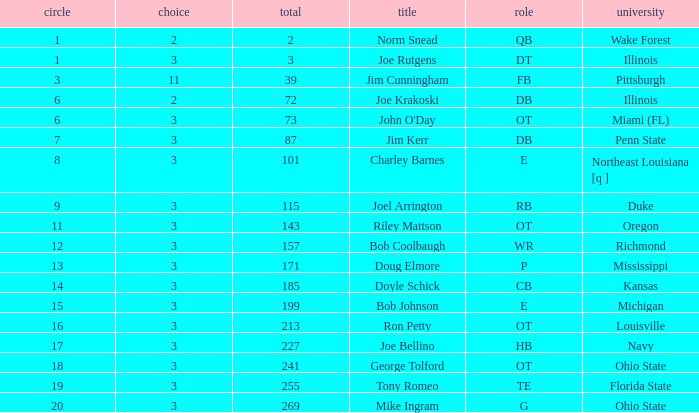Could you help me parse every detail presented in this table? {'header': ['circle', 'choice', 'total', 'title', 'role', 'university'], 'rows': [['1', '2', '2', 'Norm Snead', 'QB', 'Wake Forest'], ['1', '3', '3', 'Joe Rutgens', 'DT', 'Illinois'], ['3', '11', '39', 'Jim Cunningham', 'FB', 'Pittsburgh'], ['6', '2', '72', 'Joe Krakoski', 'DB', 'Illinois'], ['6', '3', '73', "John O'Day", 'OT', 'Miami (FL)'], ['7', '3', '87', 'Jim Kerr', 'DB', 'Penn State'], ['8', '3', '101', 'Charley Barnes', 'E', 'Northeast Louisiana [q ]'], ['9', '3', '115', 'Joel Arrington', 'RB', 'Duke'], ['11', '3', '143', 'Riley Mattson', 'OT', 'Oregon'], ['12', '3', '157', 'Bob Coolbaugh', 'WR', 'Richmond'], ['13', '3', '171', 'Doug Elmore', 'P', 'Mississippi'], ['14', '3', '185', 'Doyle Schick', 'CB', 'Kansas'], ['15', '3', '199', 'Bob Johnson', 'E', 'Michigan'], ['16', '3', '213', 'Ron Petty', 'OT', 'Louisville'], ['17', '3', '227', 'Joe Bellino', 'HB', 'Navy'], ['18', '3', '241', 'George Tolford', 'OT', 'Ohio State'], ['19', '3', '255', 'Tony Romeo', 'TE', 'Florida State'], ['20', '3', '269', 'Mike Ingram', 'G', 'Ohio State']]} How many overalls have charley barnes as the name, with a pick less than 3? None. 